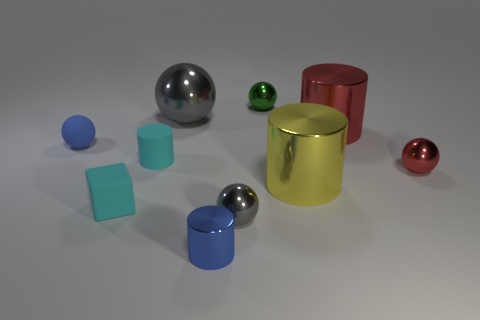What is the shape of the tiny gray thing that is the same material as the green ball? The tiny gray object is a sphere, similar in shape to the larger green ball situated nearby. In fact, both items share not only the spherical shape but also a reflective surface texture, which suggests they could be made of a similar material, possibly a polished metal or plastic with a chrome finish. 